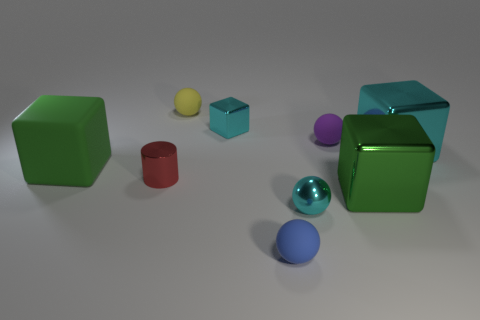The shiny object that is the same color as the big rubber thing is what size?
Keep it short and to the point. Large. What number of other objects are the same size as the cyan sphere?
Offer a terse response. 5. Do the cube that is on the left side of the yellow matte ball and the small cylinder have the same color?
Provide a short and direct response. No. Is the number of large green blocks that are behind the purple ball greater than the number of small metal cubes?
Provide a succinct answer. No. Is there anything else that has the same color as the small block?
Ensure brevity in your answer.  Yes. What is the shape of the metal object that is in front of the large green object on the right side of the yellow sphere?
Keep it short and to the point. Sphere. Is the number of small cyan blocks greater than the number of big gray spheres?
Your response must be concise. Yes. What number of metal objects are both behind the tiny shiny sphere and right of the small cyan block?
Your response must be concise. 2. There is a sphere in front of the shiny sphere; how many blue matte objects are on the right side of it?
Give a very brief answer. 0. How many things are big objects that are in front of the large green matte object or green things in front of the small cylinder?
Provide a short and direct response. 1. 